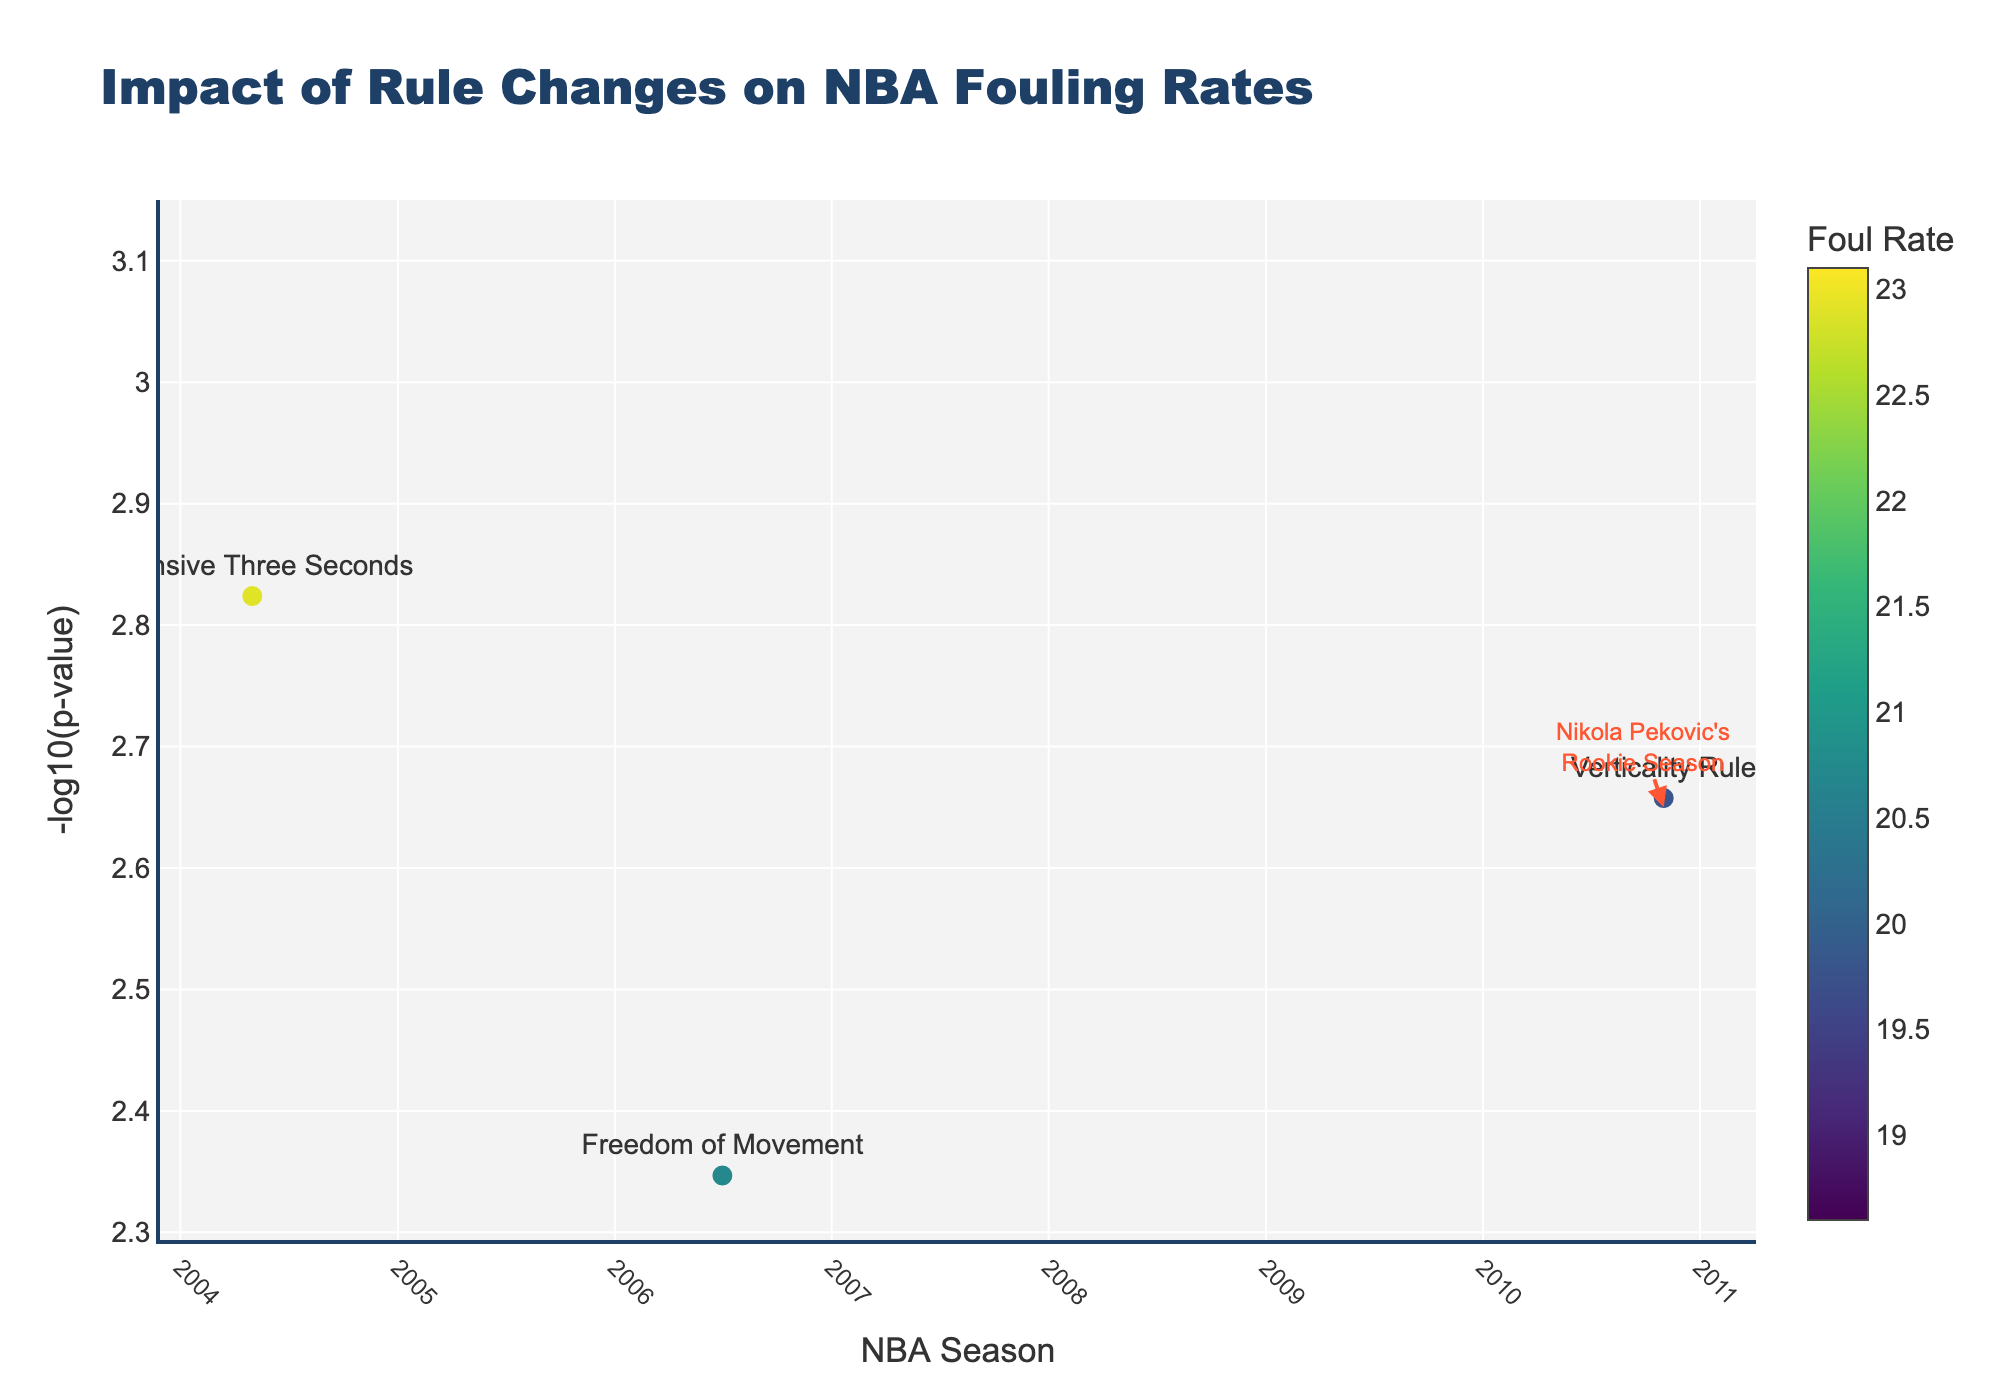What's the title of the plot? Look at the top center of the plot where the title is displayed. The text there gives the overall description of the plot.
Answer: Impact of Rule Changes on NBA Fouling Rates Which season had the lowest foul rate? Inspect the hover text when you place the cursor over each data point for the listed foul rates. Identify the lowest one.
Answer: 2021-22 What does the y-axis represent? Observe the y-axis label, which typically explains what is being measured or represented on that axis.
Answer: -log10(p-value) Which rule change corresponds to the highest foul rate observed? Hover over each data point looking at the foul rates in the hover text, and identify the highest rate.
Answer: Hand Checking In which season did the "Defensive Three Seconds" rule change occur? Use the hover text to find "Defensive Three Seconds" and see which season it corresponds to.
Answer: 2004-05 Comparing the rule changes "Hand Checking" and "Non-Basketball Move", which had a more statistically significant impact, and how can you tell? The significance is indicated by the -log10(p-value). The higher the value, the more significant the impact. Compare the y-values for both rule changes. "Non-Basketball Move" has a higher y-value.
Answer: Non-Basketball Move What defensive strategy shift is associated with the "Freedom of Movement" rule change? Hover over the data point for "Freedom of Movement" to see the associated defensive strategy shift in the hover text.
Answer: Switch-Heavy True or False: The season highlighted by the annotation also has the most significant p-value. Find the season highlighted by the annotation and compare its -log10(p-value) with others.
Answer: False Which year is specifically highlighted with an annotation, and what is mentioned in the annotation? Look for any marked annotation in the plot, specifically around points that are called out with arrows or extra text.
Answer: 2010-11, Nikola Pekovic's Rookie Season How does the foul rate trend change from the 1984-85 season to the 2021-22 season? Compare the foul rates in the hover texts from the 1984-85 and 2021-22 seasons to observe the change over time.
Answer: It decreases from 22.5 to 18.6 